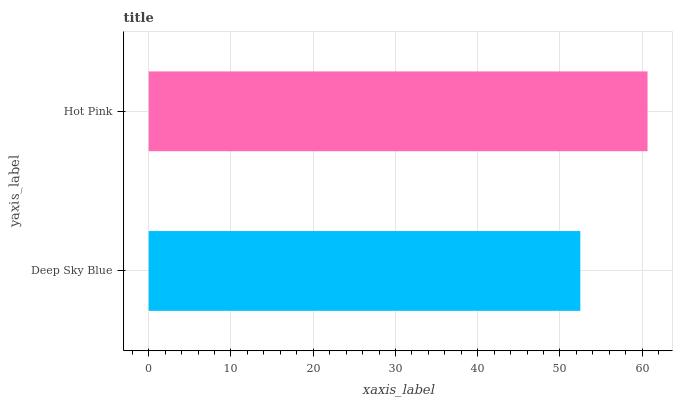Is Deep Sky Blue the minimum?
Answer yes or no. Yes. Is Hot Pink the maximum?
Answer yes or no. Yes. Is Hot Pink the minimum?
Answer yes or no. No. Is Hot Pink greater than Deep Sky Blue?
Answer yes or no. Yes. Is Deep Sky Blue less than Hot Pink?
Answer yes or no. Yes. Is Deep Sky Blue greater than Hot Pink?
Answer yes or no. No. Is Hot Pink less than Deep Sky Blue?
Answer yes or no. No. Is Hot Pink the high median?
Answer yes or no. Yes. Is Deep Sky Blue the low median?
Answer yes or no. Yes. Is Deep Sky Blue the high median?
Answer yes or no. No. Is Hot Pink the low median?
Answer yes or no. No. 